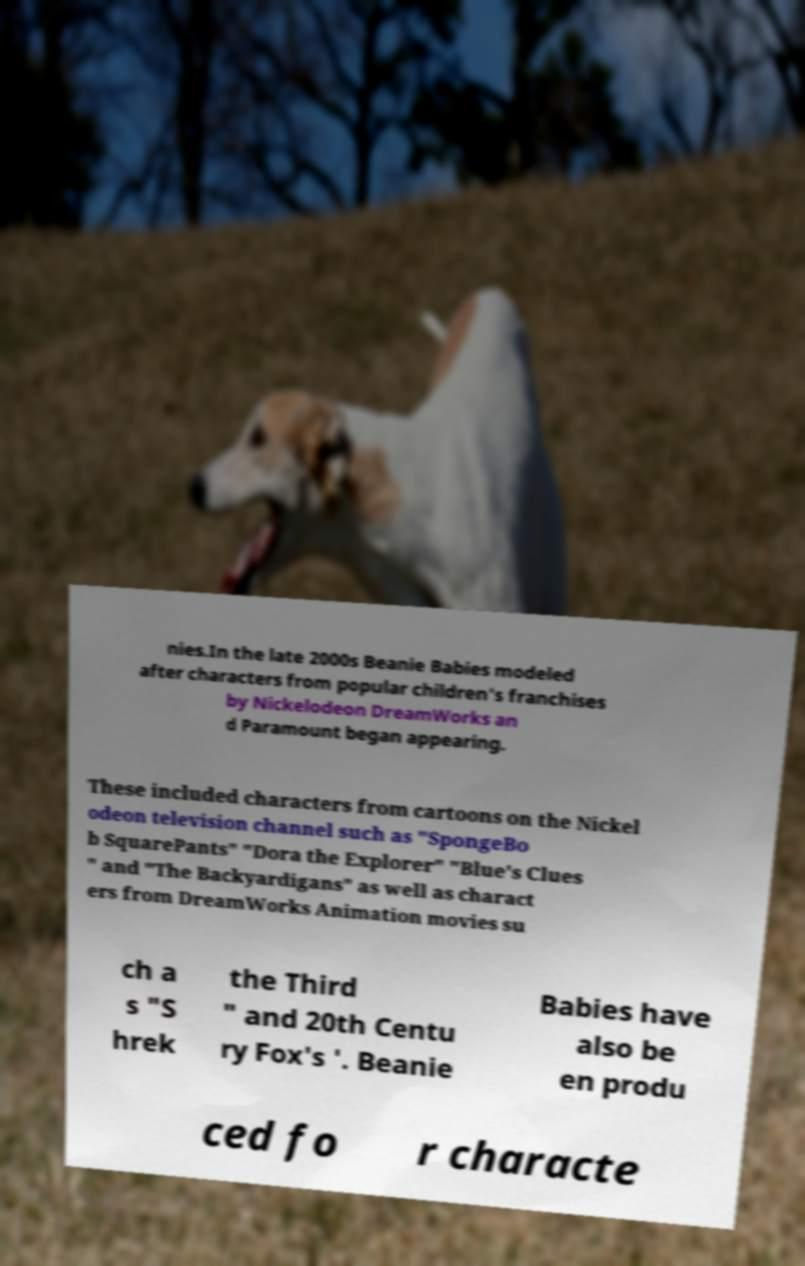Can you read and provide the text displayed in the image?This photo seems to have some interesting text. Can you extract and type it out for me? nies.In the late 2000s Beanie Babies modeled after characters from popular children's franchises by Nickelodeon DreamWorks an d Paramount began appearing. These included characters from cartoons on the Nickel odeon television channel such as "SpongeBo b SquarePants" "Dora the Explorer" "Blue's Clues " and "The Backyardigans" as well as charact ers from DreamWorks Animation movies su ch a s "S hrek the Third " and 20th Centu ry Fox's '. Beanie Babies have also be en produ ced fo r characte 